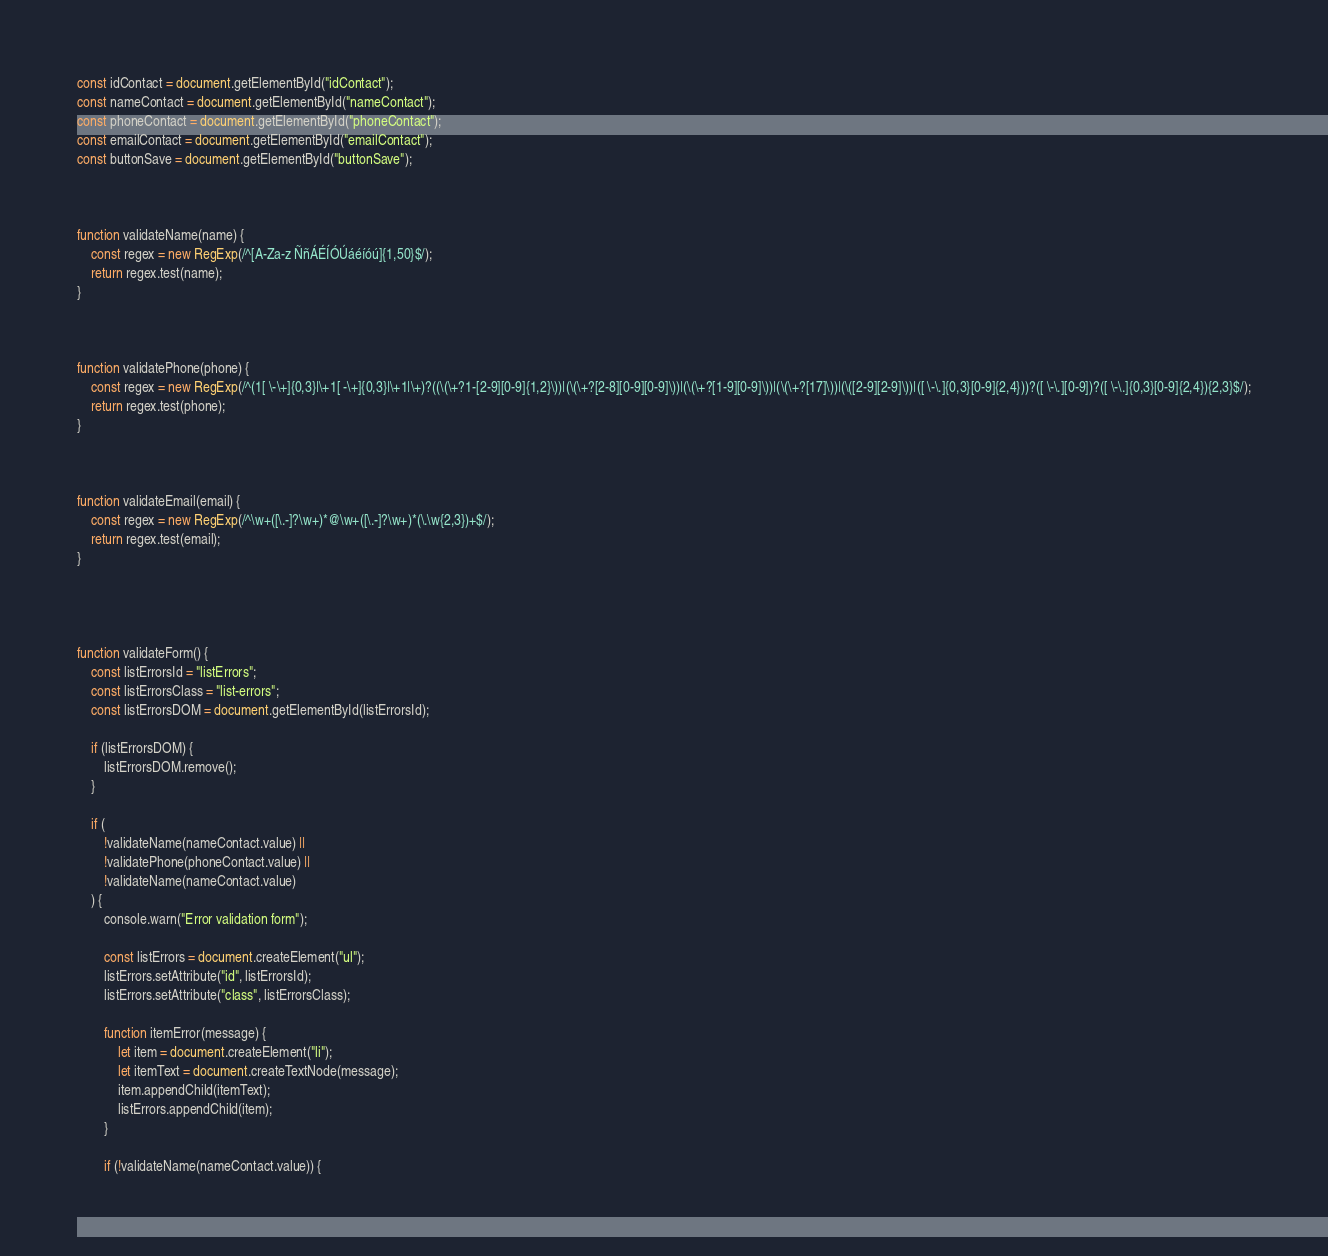<code> <loc_0><loc_0><loc_500><loc_500><_JavaScript_>
const idContact = document.getElementById("idContact");
const nameContact = document.getElementById("nameContact");
const phoneContact = document.getElementById("phoneContact");
const emailContact = document.getElementById("emailContact");
const buttonSave = document.getElementById("buttonSave");



function validateName(name) {
	const regex = new RegExp(/^[A-Za-z ÑñÁÉÍÓÚáéíóú]{1,50}$/);
	return regex.test(name);
}



function validatePhone(phone) {
	const regex = new RegExp(/^(1[ \-\+]{0,3}|\+1[ -\+]{0,3}|\+1|\+)?((\(\+?1-[2-9][0-9]{1,2}\))|(\(\+?[2-8][0-9][0-9]\))|(\(\+?[1-9][0-9]\))|(\(\+?[17]\))|(\([2-9][2-9]\))|([ \-\.]{0,3}[0-9]{2,4}))?([ \-\.][0-9])?([ \-\.]{0,3}[0-9]{2,4}){2,3}$/);
	return regex.test(phone);
}



function validateEmail(email) {
	const regex = new RegExp(/^\w+([\.-]?\w+)*@\w+([\.-]?\w+)*(\.\w{2,3})+$/);
	return regex.test(email);
}




function validateForm() {
	const listErrorsId = "listErrors";
	const listErrorsClass = "list-errors";
	const listErrorsDOM = document.getElementById(listErrorsId);

	if (listErrorsDOM) {
		listErrorsDOM.remove();
	}

	if (
		!validateName(nameContact.value) ||
		!validatePhone(phoneContact.value) ||
		!validateName(nameContact.value)
	) {
		console.warn("Error validation form");

		const listErrors = document.createElement("ul");
		listErrors.setAttribute("id", listErrorsId);
		listErrors.setAttribute("class", listErrorsClass);

		function itemError(message) {
			let item = document.createElement("li");
			let itemText = document.createTextNode(message);
			item.appendChild(itemText);
			listErrors.appendChild(item);
		}

		if (!validateName(nameContact.value)) {</code> 